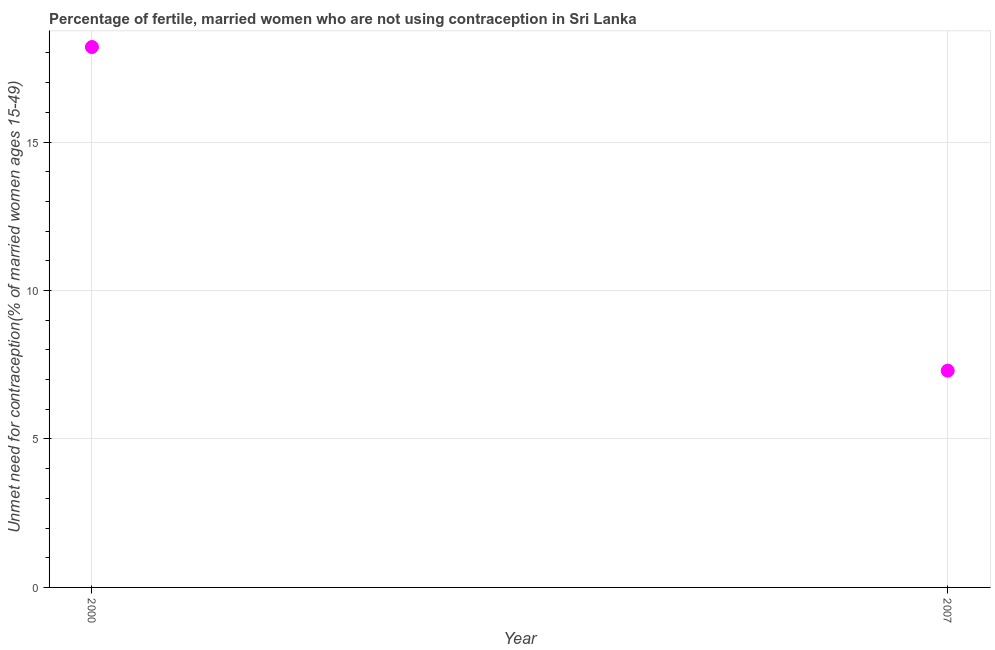What is the number of married women who are not using contraception in 2000?
Keep it short and to the point. 18.2. Across all years, what is the maximum number of married women who are not using contraception?
Your answer should be compact. 18.2. In which year was the number of married women who are not using contraception maximum?
Your answer should be compact. 2000. In which year was the number of married women who are not using contraception minimum?
Provide a succinct answer. 2007. What is the sum of the number of married women who are not using contraception?
Give a very brief answer. 25.5. What is the difference between the number of married women who are not using contraception in 2000 and 2007?
Ensure brevity in your answer.  10.9. What is the average number of married women who are not using contraception per year?
Provide a succinct answer. 12.75. What is the median number of married women who are not using contraception?
Offer a terse response. 12.75. Do a majority of the years between 2007 and 2000 (inclusive) have number of married women who are not using contraception greater than 15 %?
Your answer should be compact. No. What is the ratio of the number of married women who are not using contraception in 2000 to that in 2007?
Keep it short and to the point. 2.49. In how many years, is the number of married women who are not using contraception greater than the average number of married women who are not using contraception taken over all years?
Provide a succinct answer. 1. How many years are there in the graph?
Give a very brief answer. 2. Are the values on the major ticks of Y-axis written in scientific E-notation?
Keep it short and to the point. No. Does the graph contain any zero values?
Make the answer very short. No. Does the graph contain grids?
Make the answer very short. Yes. What is the title of the graph?
Give a very brief answer. Percentage of fertile, married women who are not using contraception in Sri Lanka. What is the label or title of the X-axis?
Make the answer very short. Year. What is the label or title of the Y-axis?
Provide a short and direct response.  Unmet need for contraception(% of married women ages 15-49). What is the  Unmet need for contraception(% of married women ages 15-49) in 2000?
Make the answer very short. 18.2. What is the ratio of the  Unmet need for contraception(% of married women ages 15-49) in 2000 to that in 2007?
Provide a succinct answer. 2.49. 